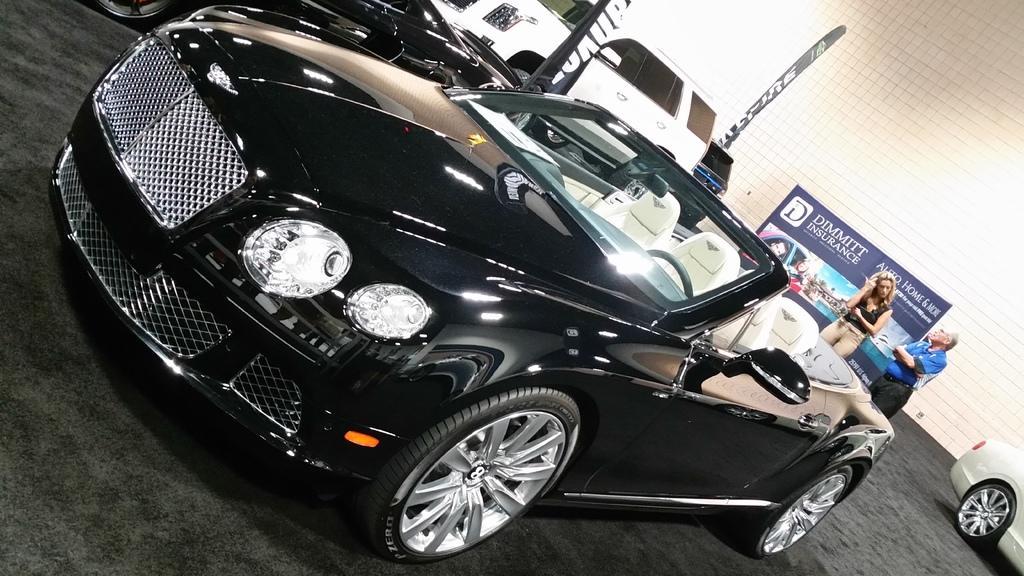In one or two sentences, can you explain what this image depicts? In this picture we can see a few vehicles. There is a man and a woman standing. We can see a poster and a wall in the background. 